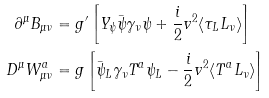<formula> <loc_0><loc_0><loc_500><loc_500>\partial ^ { \mu } B _ { \mu \nu } & = g ^ { \prime } \left [ Y _ { \psi } { \bar { \psi } } \gamma _ { \nu } \psi + \frac { i } { 2 } v ^ { 2 } \langle \tau _ { L } L _ { \nu } \rangle \right ] \\ D ^ { \mu } W _ { \mu \nu } ^ { a } & = g \left [ { \bar { \psi } } _ { L } \gamma _ { \nu } T ^ { a } \psi _ { L } - \frac { i } { 2 } v ^ { 2 } \langle T ^ { a } L _ { \nu } \rangle \right ]</formula> 